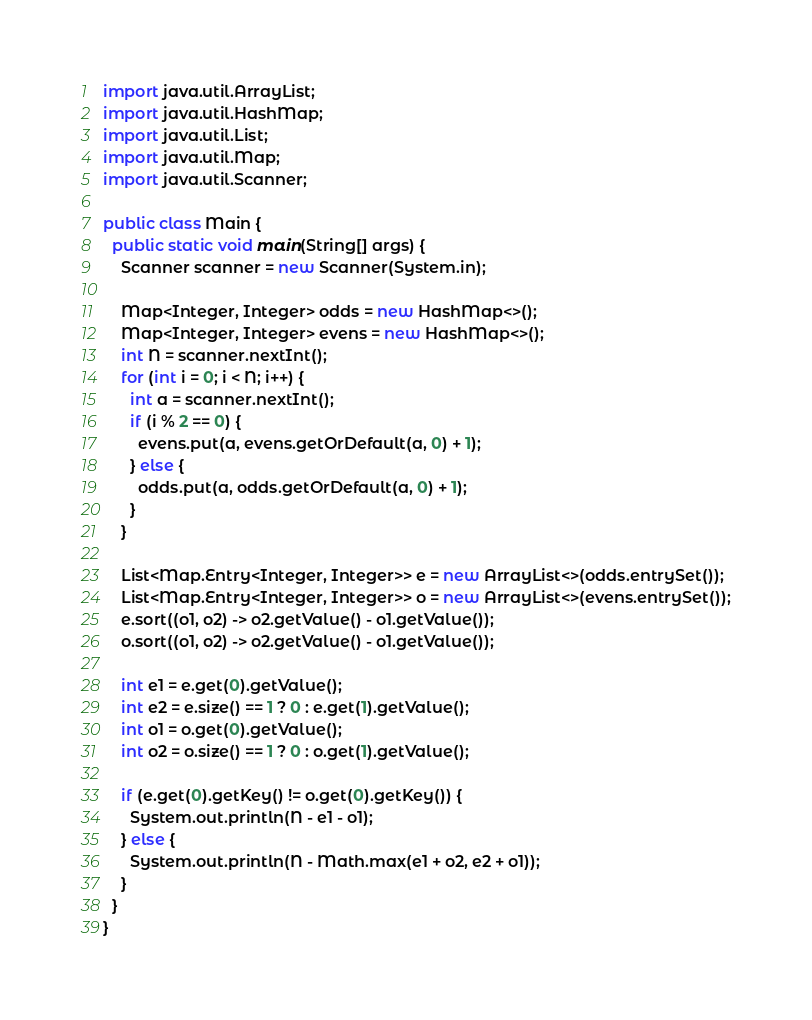Convert code to text. <code><loc_0><loc_0><loc_500><loc_500><_Java_>import java.util.ArrayList;
import java.util.HashMap;
import java.util.List;
import java.util.Map;
import java.util.Scanner;

public class Main {
  public static void main(String[] args) {
    Scanner scanner = new Scanner(System.in);

    Map<Integer, Integer> odds = new HashMap<>();
    Map<Integer, Integer> evens = new HashMap<>();
    int N = scanner.nextInt();
    for (int i = 0; i < N; i++) {
      int a = scanner.nextInt();
      if (i % 2 == 0) {
        evens.put(a, evens.getOrDefault(a, 0) + 1);
      } else {
        odds.put(a, odds.getOrDefault(a, 0) + 1);
      }
    }

    List<Map.Entry<Integer, Integer>> e = new ArrayList<>(odds.entrySet());
    List<Map.Entry<Integer, Integer>> o = new ArrayList<>(evens.entrySet());
    e.sort((o1, o2) -> o2.getValue() - o1.getValue());
    o.sort((o1, o2) -> o2.getValue() - o1.getValue());

    int e1 = e.get(0).getValue();
    int e2 = e.size() == 1 ? 0 : e.get(1).getValue();
    int o1 = o.get(0).getValue();
    int o2 = o.size() == 1 ? 0 : o.get(1).getValue();

    if (e.get(0).getKey() != o.get(0).getKey()) {
      System.out.println(N - e1 - o1);
    } else {
      System.out.println(N - Math.max(e1 + o2, e2 + o1));
    }
  }
}
</code> 